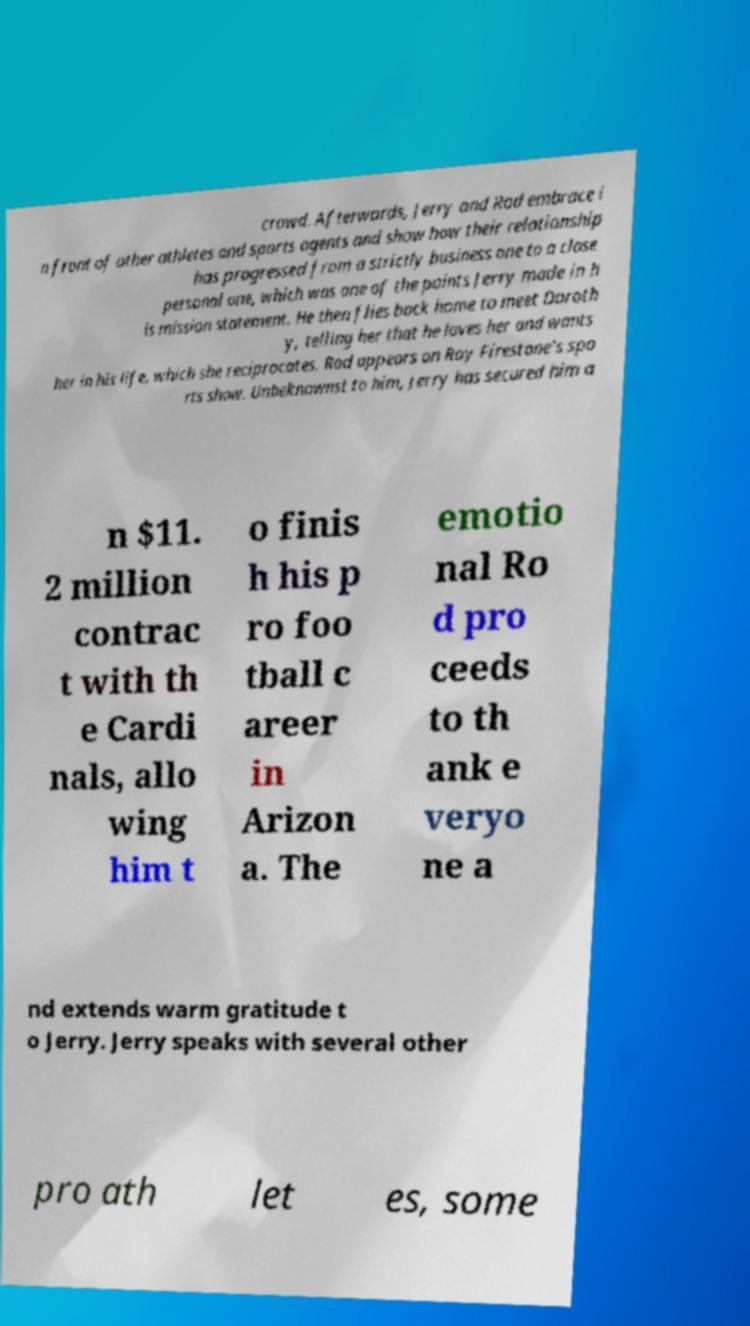Could you extract and type out the text from this image? crowd. Afterwards, Jerry and Rod embrace i n front of other athletes and sports agents and show how their relationship has progressed from a strictly business one to a close personal one, which was one of the points Jerry made in h is mission statement. He then flies back home to meet Doroth y, telling her that he loves her and wants her in his life, which she reciprocates. Rod appears on Roy Firestone's spo rts show. Unbeknownst to him, Jerry has secured him a n $11. 2 million contrac t with th e Cardi nals, allo wing him t o finis h his p ro foo tball c areer in Arizon a. The emotio nal Ro d pro ceeds to th ank e veryo ne a nd extends warm gratitude t o Jerry. Jerry speaks with several other pro ath let es, some 